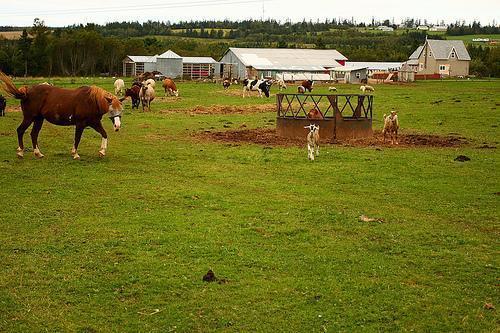How many horses are pictured?
Give a very brief answer. 1. 